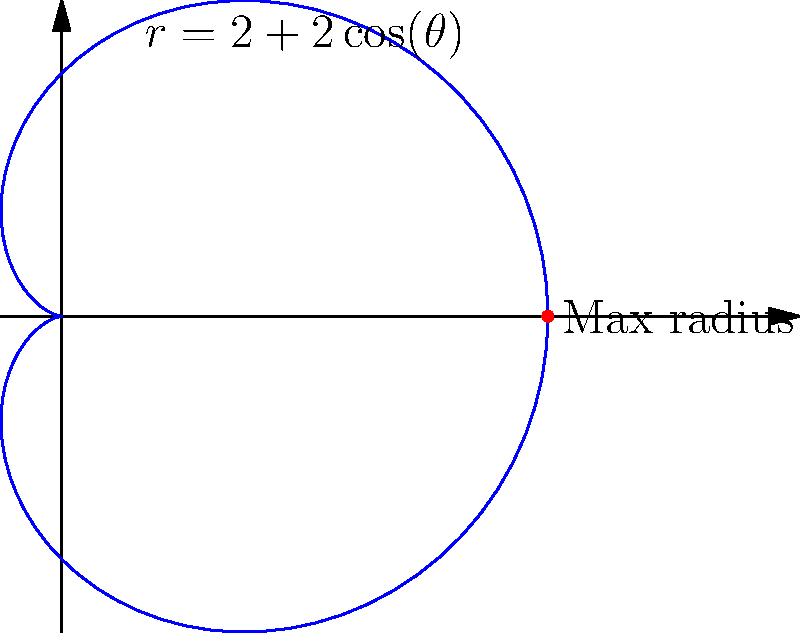As an entrepreneur planning to expand your customer reach, you model your market penetration using a cardioid shape represented by the polar equation $r = 2 + 2\cos(\theta)$. What is the maximum radius of this cardioid, representing the furthest extent of your customer reach? To find the maximum radius of the cardioid, we can follow these steps:

1) The general equation of a cardioid is $r = a(1 + \cos(\theta))$, where $a$ is a constant.

2) In our case, $r = 2 + 2\cos(\theta)$, so $a = 2$.

3) The maximum radius occurs when $\cos(\theta) = 1$, which happens when $\theta = 0$ or $2\pi$.

4) At this point, the radius is:

   $r_{max} = 2 + 2(1) = 4$

5) We can verify this by substituting different values of $\theta$ into the equation and seeing that no value gives a larger result.

This maximum radius represents the furthest reach of your customer base according to this model.
Answer: 4 